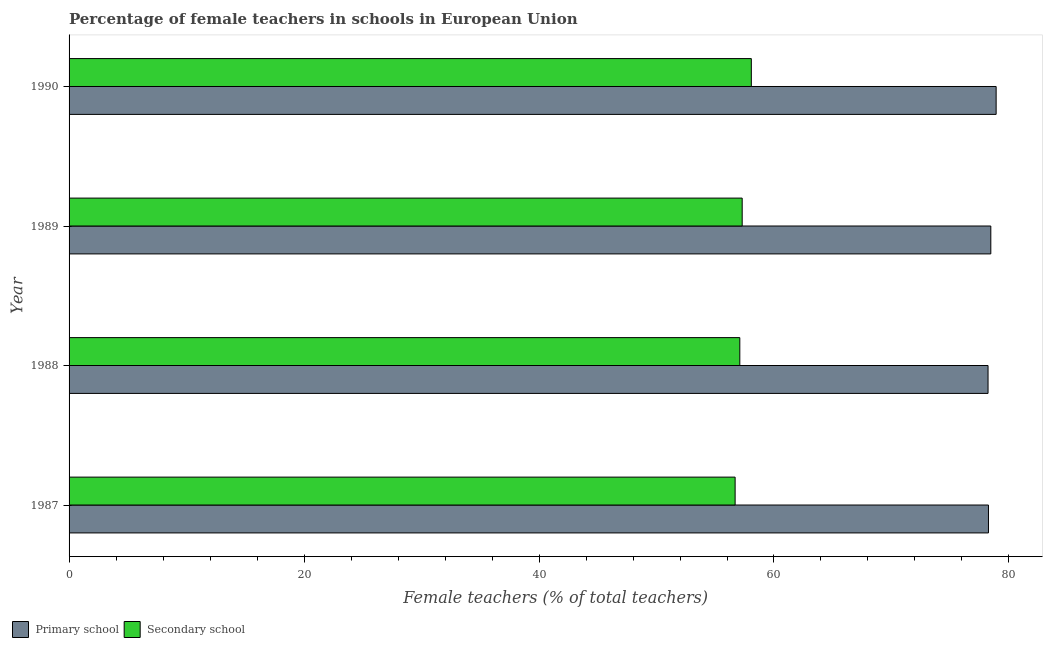How many groups of bars are there?
Offer a terse response. 4. Are the number of bars on each tick of the Y-axis equal?
Offer a very short reply. Yes. How many bars are there on the 4th tick from the top?
Your answer should be very brief. 2. How many bars are there on the 2nd tick from the bottom?
Your response must be concise. 2. What is the label of the 4th group of bars from the top?
Provide a short and direct response. 1987. In how many cases, is the number of bars for a given year not equal to the number of legend labels?
Make the answer very short. 0. What is the percentage of female teachers in secondary schools in 1987?
Offer a terse response. 56.69. Across all years, what is the maximum percentage of female teachers in secondary schools?
Give a very brief answer. 58.07. Across all years, what is the minimum percentage of female teachers in secondary schools?
Give a very brief answer. 56.69. In which year was the percentage of female teachers in primary schools maximum?
Your response must be concise. 1990. What is the total percentage of female teachers in secondary schools in the graph?
Offer a very short reply. 229.15. What is the difference between the percentage of female teachers in secondary schools in 1987 and that in 1989?
Offer a very short reply. -0.6. What is the difference between the percentage of female teachers in secondary schools in 1987 and the percentage of female teachers in primary schools in 1989?
Give a very brief answer. -21.76. What is the average percentage of female teachers in primary schools per year?
Your answer should be very brief. 78.46. In the year 1989, what is the difference between the percentage of female teachers in secondary schools and percentage of female teachers in primary schools?
Provide a succinct answer. -21.16. In how many years, is the percentage of female teachers in secondary schools greater than 36 %?
Offer a terse response. 4. What is the ratio of the percentage of female teachers in primary schools in 1988 to that in 1990?
Your answer should be compact. 0.99. Is the difference between the percentage of female teachers in secondary schools in 1987 and 1990 greater than the difference between the percentage of female teachers in primary schools in 1987 and 1990?
Offer a terse response. No. What is the difference between the highest and the second highest percentage of female teachers in secondary schools?
Offer a very short reply. 0.78. What is the difference between the highest and the lowest percentage of female teachers in secondary schools?
Offer a terse response. 1.38. What does the 1st bar from the top in 1990 represents?
Provide a short and direct response. Secondary school. What does the 2nd bar from the bottom in 1987 represents?
Offer a very short reply. Secondary school. Are all the bars in the graph horizontal?
Give a very brief answer. Yes. How many years are there in the graph?
Offer a terse response. 4. Where does the legend appear in the graph?
Ensure brevity in your answer.  Bottom left. How are the legend labels stacked?
Make the answer very short. Horizontal. What is the title of the graph?
Offer a very short reply. Percentage of female teachers in schools in European Union. What is the label or title of the X-axis?
Your answer should be compact. Female teachers (% of total teachers). What is the label or title of the Y-axis?
Your answer should be compact. Year. What is the Female teachers (% of total teachers) of Primary school in 1987?
Your response must be concise. 78.26. What is the Female teachers (% of total teachers) in Secondary school in 1987?
Offer a terse response. 56.69. What is the Female teachers (% of total teachers) in Primary school in 1988?
Your answer should be very brief. 78.22. What is the Female teachers (% of total teachers) in Secondary school in 1988?
Your answer should be very brief. 57.09. What is the Female teachers (% of total teachers) in Primary school in 1989?
Ensure brevity in your answer.  78.46. What is the Female teachers (% of total teachers) of Secondary school in 1989?
Provide a short and direct response. 57.29. What is the Female teachers (% of total teachers) of Primary school in 1990?
Offer a very short reply. 78.91. What is the Female teachers (% of total teachers) in Secondary school in 1990?
Your answer should be very brief. 58.07. Across all years, what is the maximum Female teachers (% of total teachers) in Primary school?
Give a very brief answer. 78.91. Across all years, what is the maximum Female teachers (% of total teachers) in Secondary school?
Keep it short and to the point. 58.07. Across all years, what is the minimum Female teachers (% of total teachers) of Primary school?
Ensure brevity in your answer.  78.22. Across all years, what is the minimum Female teachers (% of total teachers) of Secondary school?
Keep it short and to the point. 56.69. What is the total Female teachers (% of total teachers) of Primary school in the graph?
Keep it short and to the point. 313.84. What is the total Female teachers (% of total teachers) of Secondary school in the graph?
Your response must be concise. 229.15. What is the difference between the Female teachers (% of total teachers) of Primary school in 1987 and that in 1988?
Your answer should be compact. 0.04. What is the difference between the Female teachers (% of total teachers) of Secondary school in 1987 and that in 1988?
Ensure brevity in your answer.  -0.4. What is the difference between the Female teachers (% of total teachers) of Primary school in 1987 and that in 1989?
Offer a very short reply. -0.2. What is the difference between the Female teachers (% of total teachers) of Secondary school in 1987 and that in 1989?
Your response must be concise. -0.6. What is the difference between the Female teachers (% of total teachers) of Primary school in 1987 and that in 1990?
Offer a very short reply. -0.65. What is the difference between the Female teachers (% of total teachers) of Secondary school in 1987 and that in 1990?
Provide a succinct answer. -1.38. What is the difference between the Female teachers (% of total teachers) in Primary school in 1988 and that in 1989?
Offer a terse response. -0.24. What is the difference between the Female teachers (% of total teachers) of Secondary school in 1988 and that in 1989?
Offer a terse response. -0.2. What is the difference between the Female teachers (% of total teachers) of Primary school in 1988 and that in 1990?
Your response must be concise. -0.69. What is the difference between the Female teachers (% of total teachers) of Secondary school in 1988 and that in 1990?
Provide a succinct answer. -0.98. What is the difference between the Female teachers (% of total teachers) of Primary school in 1989 and that in 1990?
Your response must be concise. -0.45. What is the difference between the Female teachers (% of total teachers) in Secondary school in 1989 and that in 1990?
Provide a succinct answer. -0.78. What is the difference between the Female teachers (% of total teachers) in Primary school in 1987 and the Female teachers (% of total teachers) in Secondary school in 1988?
Your answer should be very brief. 21.16. What is the difference between the Female teachers (% of total teachers) of Primary school in 1987 and the Female teachers (% of total teachers) of Secondary school in 1989?
Your answer should be very brief. 20.96. What is the difference between the Female teachers (% of total teachers) in Primary school in 1987 and the Female teachers (% of total teachers) in Secondary school in 1990?
Keep it short and to the point. 20.18. What is the difference between the Female teachers (% of total teachers) in Primary school in 1988 and the Female teachers (% of total teachers) in Secondary school in 1989?
Ensure brevity in your answer.  20.93. What is the difference between the Female teachers (% of total teachers) in Primary school in 1988 and the Female teachers (% of total teachers) in Secondary school in 1990?
Provide a short and direct response. 20.15. What is the difference between the Female teachers (% of total teachers) in Primary school in 1989 and the Female teachers (% of total teachers) in Secondary school in 1990?
Provide a short and direct response. 20.38. What is the average Female teachers (% of total teachers) of Primary school per year?
Keep it short and to the point. 78.46. What is the average Female teachers (% of total teachers) in Secondary school per year?
Provide a succinct answer. 57.29. In the year 1987, what is the difference between the Female teachers (% of total teachers) of Primary school and Female teachers (% of total teachers) of Secondary school?
Your response must be concise. 21.56. In the year 1988, what is the difference between the Female teachers (% of total teachers) of Primary school and Female teachers (% of total teachers) of Secondary school?
Offer a very short reply. 21.13. In the year 1989, what is the difference between the Female teachers (% of total teachers) in Primary school and Female teachers (% of total teachers) in Secondary school?
Keep it short and to the point. 21.16. In the year 1990, what is the difference between the Female teachers (% of total teachers) of Primary school and Female teachers (% of total teachers) of Secondary school?
Make the answer very short. 20.84. What is the ratio of the Female teachers (% of total teachers) in Primary school in 1987 to that in 1989?
Your answer should be very brief. 1. What is the ratio of the Female teachers (% of total teachers) of Primary school in 1987 to that in 1990?
Your answer should be compact. 0.99. What is the ratio of the Female teachers (% of total teachers) of Secondary school in 1987 to that in 1990?
Make the answer very short. 0.98. What is the ratio of the Female teachers (% of total teachers) of Secondary school in 1988 to that in 1989?
Provide a succinct answer. 1. What is the ratio of the Female teachers (% of total teachers) in Primary school in 1988 to that in 1990?
Offer a terse response. 0.99. What is the ratio of the Female teachers (% of total teachers) of Secondary school in 1988 to that in 1990?
Give a very brief answer. 0.98. What is the ratio of the Female teachers (% of total teachers) of Secondary school in 1989 to that in 1990?
Give a very brief answer. 0.99. What is the difference between the highest and the second highest Female teachers (% of total teachers) in Primary school?
Give a very brief answer. 0.45. What is the difference between the highest and the second highest Female teachers (% of total teachers) in Secondary school?
Provide a succinct answer. 0.78. What is the difference between the highest and the lowest Female teachers (% of total teachers) of Primary school?
Offer a very short reply. 0.69. What is the difference between the highest and the lowest Female teachers (% of total teachers) of Secondary school?
Your response must be concise. 1.38. 